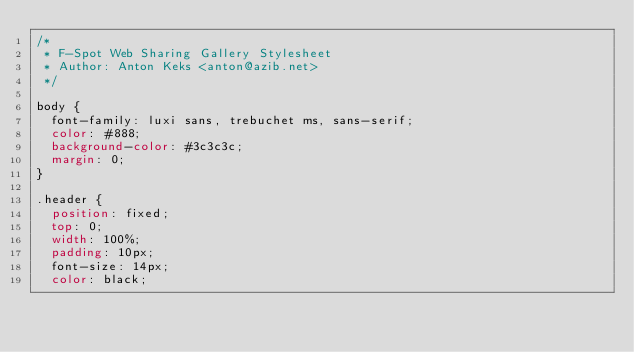<code> <loc_0><loc_0><loc_500><loc_500><_CSS_>/*
 * F-Spot Web Sharing Gallery Stylesheet
 * Author: Anton Keks <anton@azib.net>
 */

body {
  font-family: luxi sans, trebuchet ms, sans-serif;
  color: #888;
  background-color: #3c3c3c;
  margin: 0;
}

.header {
  position: fixed;
  top: 0;
  width: 100%;
  padding: 10px;
  font-size: 14px;
  color: black;</code> 